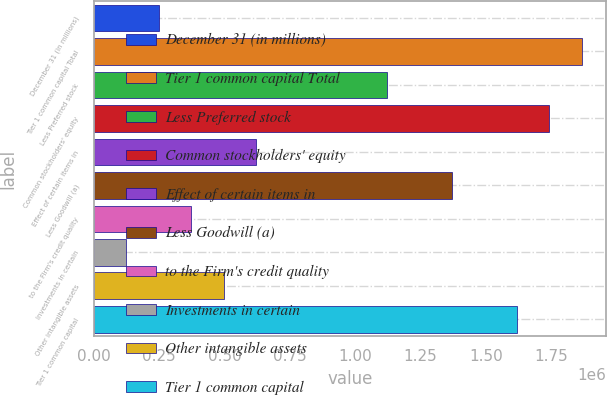Convert chart to OTSL. <chart><loc_0><loc_0><loc_500><loc_500><bar_chart><fcel>December 31 (in millions)<fcel>Tier 1 common capital Total<fcel>Less Preferred stock<fcel>Common stockholders' equity<fcel>Effect of certain items in<fcel>Less Goodwill (a)<fcel>to the Firm's credit quality<fcel>Investments in certain<fcel>Other intangible assets<fcel>Tier 1 common capital<nl><fcel>249116<fcel>1.86687e+06<fcel>1.12022e+06<fcel>1.74243e+06<fcel>622444<fcel>1.3691e+06<fcel>373559<fcel>124673<fcel>498002<fcel>1.61799e+06<nl></chart> 